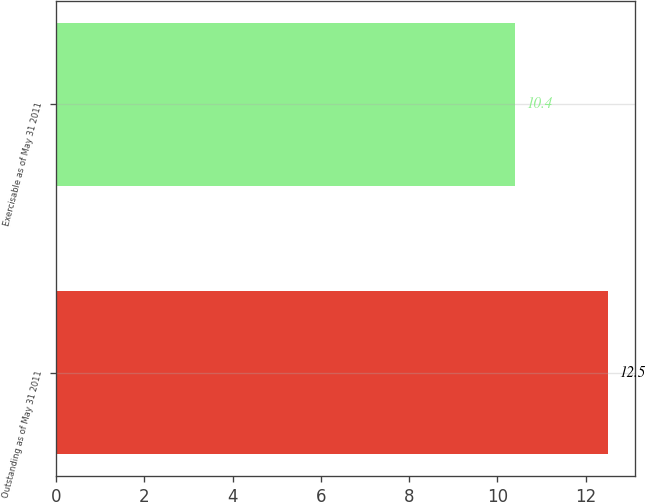Convert chart. <chart><loc_0><loc_0><loc_500><loc_500><bar_chart><fcel>Outstanding as of May 31 2011<fcel>Exercisable as of May 31 2011<nl><fcel>12.5<fcel>10.4<nl></chart> 